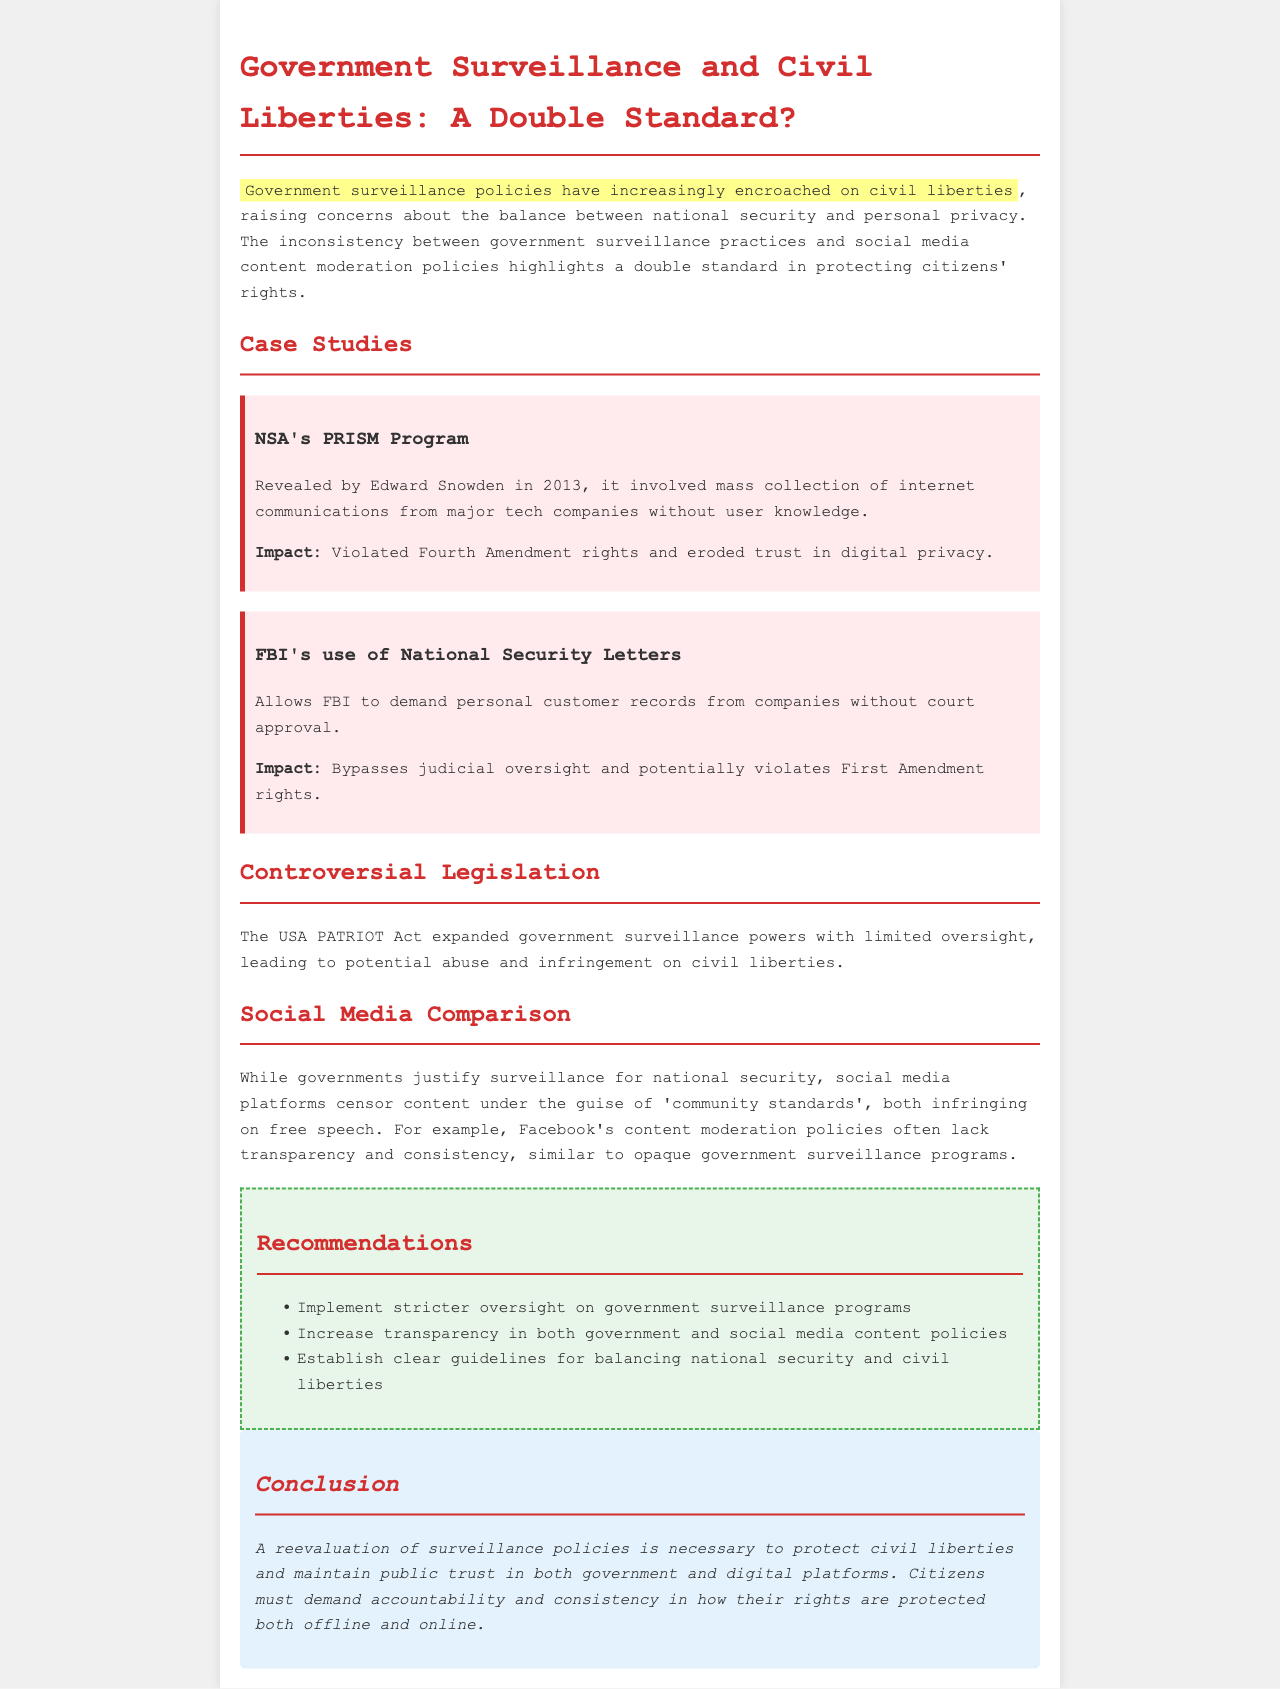What program was revealed by Edward Snowden in 2013? The program revealed by Edward Snowden in 2013 is NSA's PRISM Program.
Answer: NSA's PRISM Program What amendment's rights were violated by the NSA's actions? The Fourth Amendment rights were violated by the NSA's actions.
Answer: Fourth Amendment What allows the FBI to demand personal records without court approval? The FBI's use of National Security Letters allows this action.
Answer: National Security Letters What act expanded government surveillance powers? The USA PATRIOT Act expanded government surveillance powers.
Answer: USA PATRIOT Act What is a key recommendation regarding government surveillance programs? A key recommendation is to implement stricter oversight on government surveillance programs.
Answer: Stricter oversight Which social media platform is mentioned in the document? The social media platform mentioned in the document is Facebook.
Answer: Facebook What is the main civil liberty concern addressed in the document? The main civil liberty concern addressed is the balance between national security and personal privacy.
Answer: National security and personal privacy What is the highlighted issue regarding content moderation? The highlighted issue is the lack of transparency and consistency in content moderation policies.
Answer: Lack of transparency and consistency What is necessary to protect civil liberties according to the conclusion? A reevaluation of surveillance policies is necessary to protect civil liberties.
Answer: Reevaluation of surveillance policies 